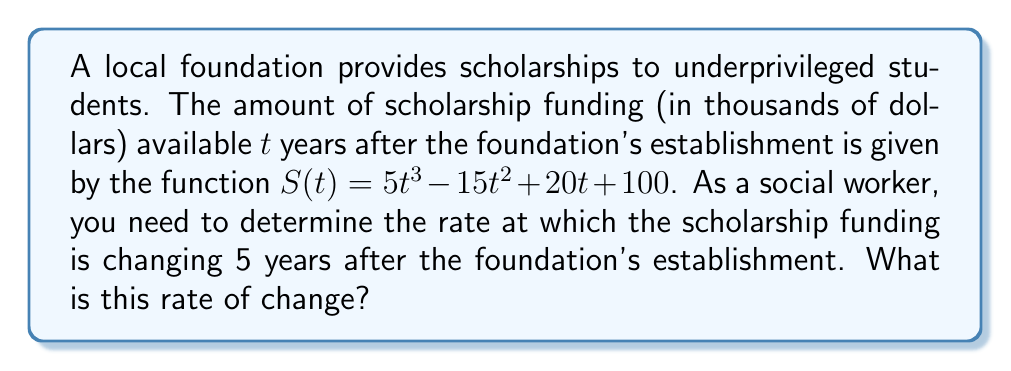Can you answer this question? To find the rate of change in scholarship funding after 5 years, we need to follow these steps:

1) The rate of change is given by the derivative of the function $S(t)$. Let's call this derivative $S'(t)$.

2) To find $S'(t)$, we differentiate $S(t)$ with respect to $t$:

   $S'(t) = \frac{d}{dt}(5t^3 - 15t^2 + 20t + 100)$

3) Using the power rule and constant rule of differentiation:

   $S'(t) = 15t^2 - 30t + 20$

4) Now that we have the rate of change function, we need to evaluate it at $t = 5$ years:

   $S'(5) = 15(5)^2 - 30(5) + 20$

5) Simplify:

   $S'(5) = 15(25) - 150 + 20$
   $S'(5) = 375 - 150 + 20$
   $S'(5) = 245$

6) Interpret the result: The rate of change after 5 years is 245 thousand dollars per year.
Answer: $245$ thousand dollars per year 